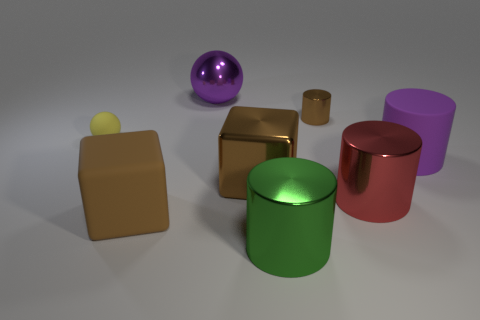Subtract all gray cylinders. Subtract all brown blocks. How many cylinders are left? 4 Add 1 large brown things. How many objects exist? 9 Subtract all blocks. How many objects are left? 6 Add 4 blocks. How many blocks exist? 6 Subtract 0 blue balls. How many objects are left? 8 Subtract all small purple matte cylinders. Subtract all brown shiny cylinders. How many objects are left? 7 Add 5 big rubber cylinders. How many big rubber cylinders are left? 6 